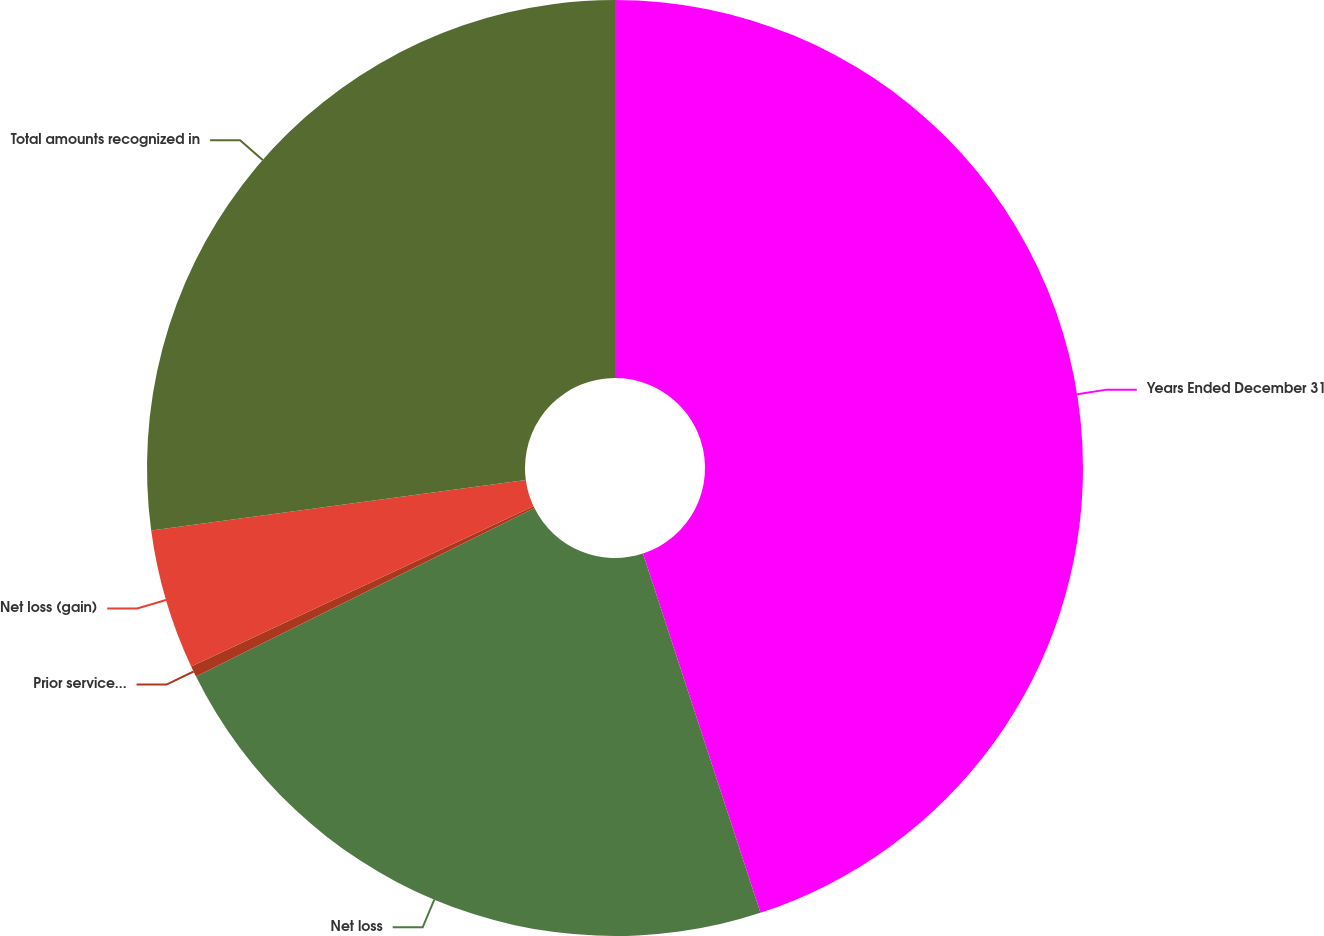Convert chart. <chart><loc_0><loc_0><loc_500><loc_500><pie_chart><fcel>Years Ended December 31<fcel>Net loss<fcel>Prior service cost (credit)<fcel>Net loss (gain)<fcel>Total amounts recognized in<nl><fcel>44.97%<fcel>22.68%<fcel>0.38%<fcel>4.84%<fcel>27.13%<nl></chart> 